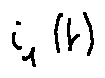<formula> <loc_0><loc_0><loc_500><loc_500>i _ { 1 } ( t )</formula> 